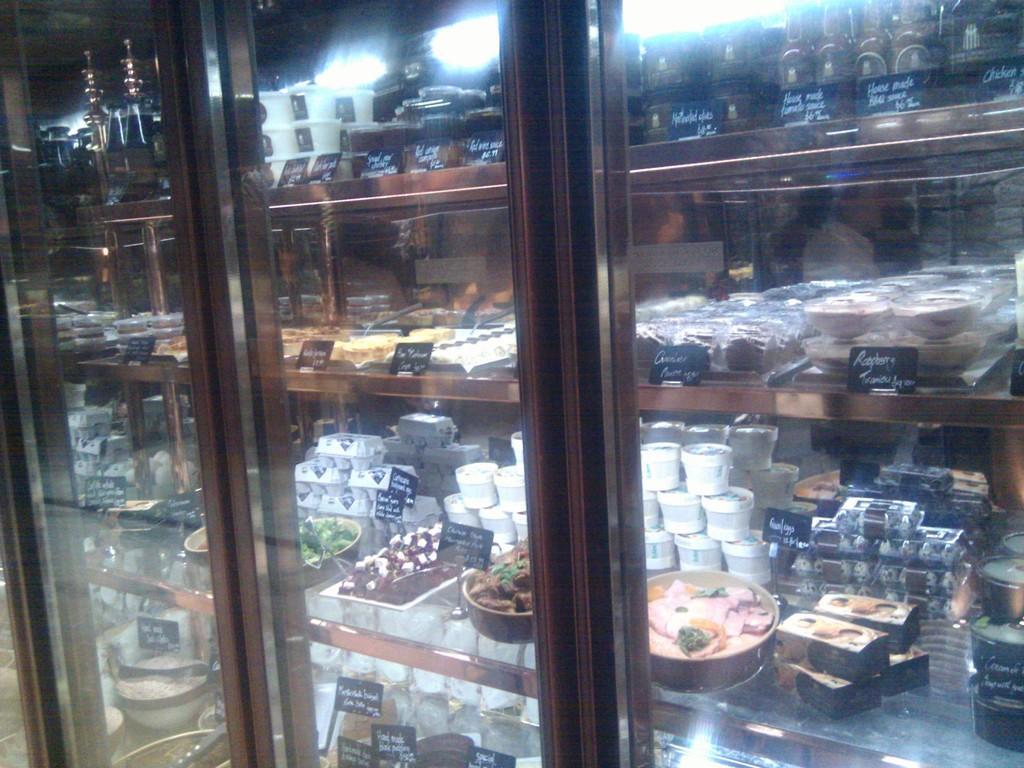Describe this image in one or two sentences. In this picture we can see a glass,from glass we can see food items and price rate boards. 